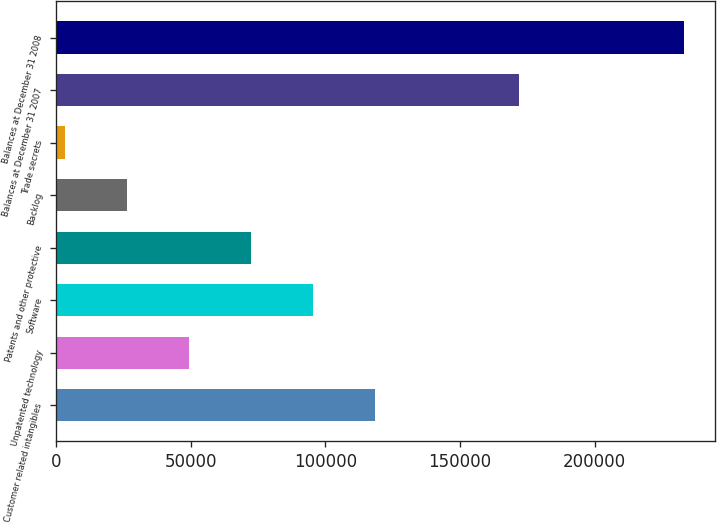Convert chart to OTSL. <chart><loc_0><loc_0><loc_500><loc_500><bar_chart><fcel>Customer related intangibles<fcel>Unpatented technology<fcel>Software<fcel>Patents and other protective<fcel>Backlog<fcel>Trade secrets<fcel>Balances at December 31 2007<fcel>Balances at December 31 2008<nl><fcel>118298<fcel>49385<fcel>95327<fcel>72356<fcel>26414<fcel>3443<fcel>171956<fcel>233153<nl></chart> 